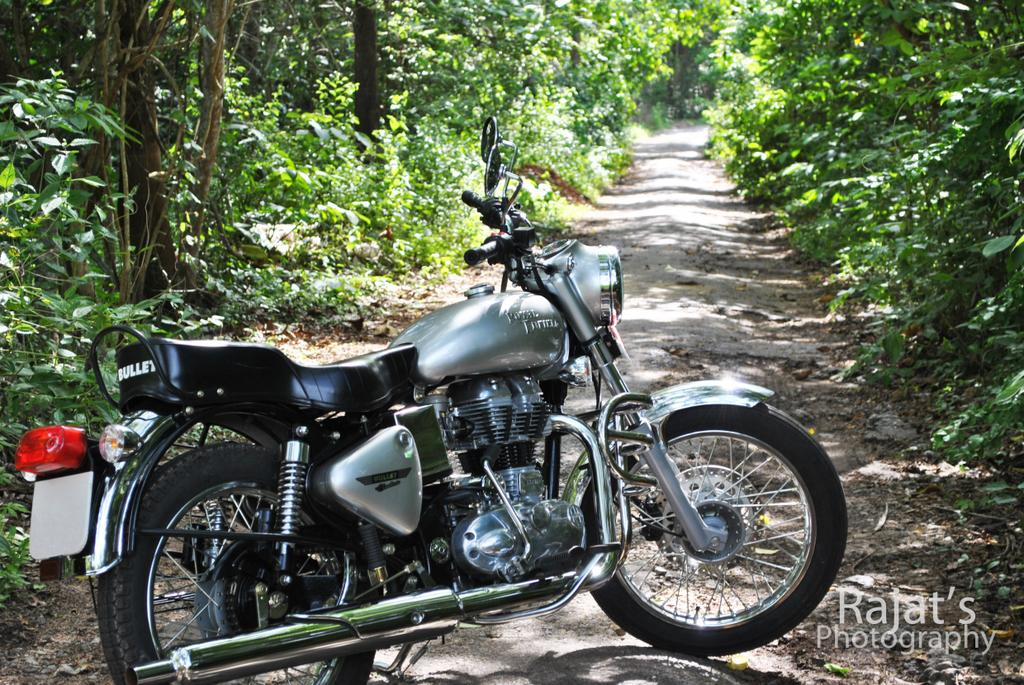What is the main subject of the image? The main subject of the image is a motorbike. Can you describe the position of the motorbike in the image? The motorbike is on the ground in the image. What can be seen in the background of the image? There are many trees on both sides of the motorbike in the image. How many ladybugs are sitting on the motorbike in the image? There are no ladybugs present on the motorbike in the image. What type of match is being played on the motorbike in the image? There is no match being played on the motorbike in the image. 